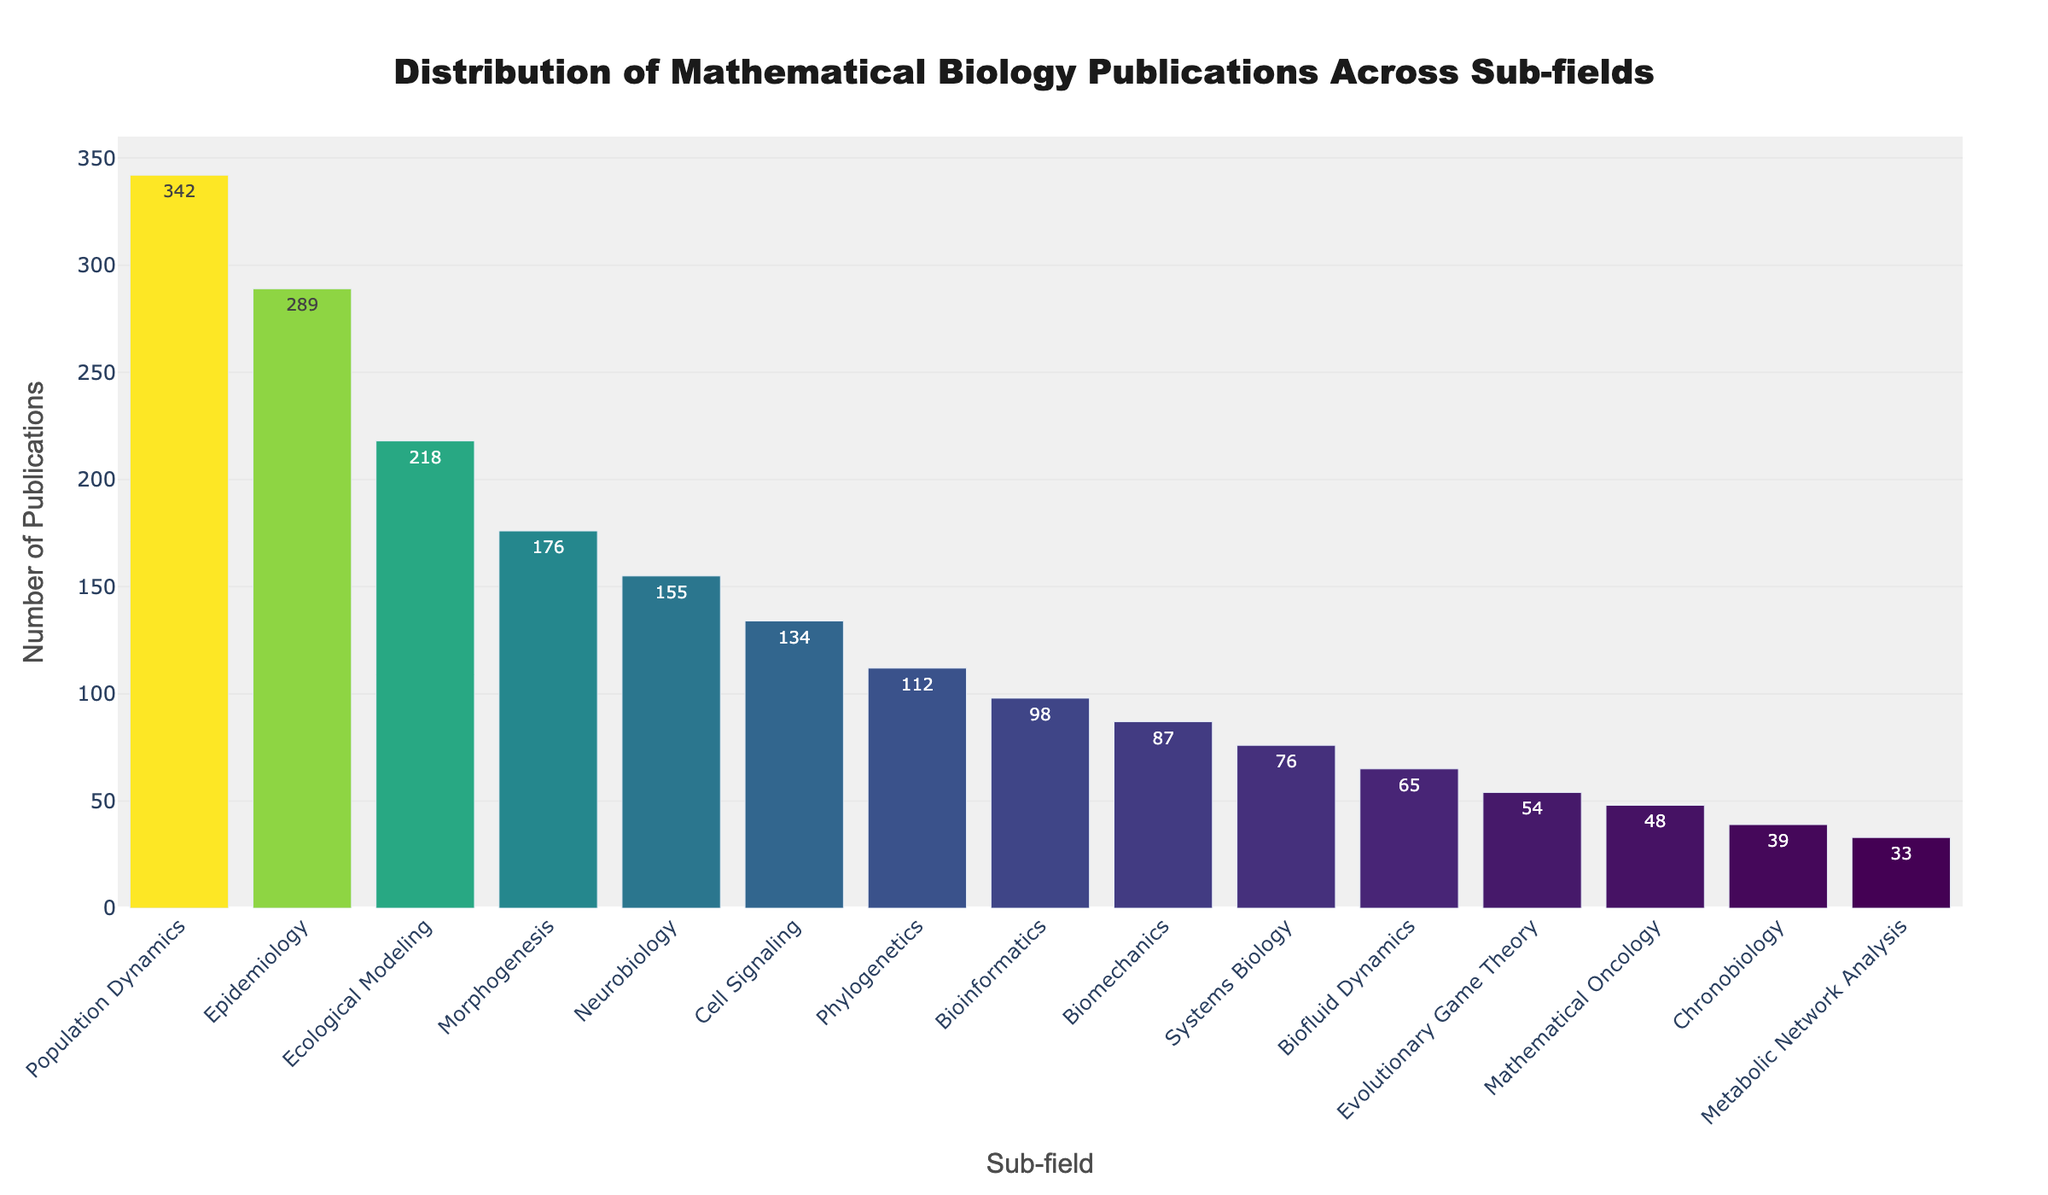What's the sub-field with the highest number of publications? The height of the bar represents the number of publications for each sub-field. The tallest bar corresponds to the sub-field with the highest number of publications. Population Dynamics has the tallest bar.
Answer: Population Dynamics What's the total number of publications in Neurobiology and Cell Signaling combined? To find the total, add the number of publications in Neurobiology (155) and Cell Signaling (134): 155 + 134 = 289.
Answer: 289 Which sub-field has fewer publications, Bioinformatics or Biomechanics? Compare the heights of the bars for Bioinformatics (98) and Biomechanics (87). Biomechanics has a shorter bar.
Answer: Biomechanics What's the difference in the number of publications between the sub-field with the most and the sub-field with the least publications? Subtract the number of publications in the sub-field with the least publications (Metabolic Network Analysis, 33) from the one with the most (Population Dynamics, 342): 342 - 33 = 309.
Answer: 309 How do the numbers of publications in Epidemiology and Evolutionary Game Theory compare? Compare the heights of the bars for Epidemiology (289) and Evolutionary Game Theory (54). Epidemiology has a higher number of publications.
Answer: Epidemiology What's the average number of publications among the top three sub-fields? The top three sub-fields by number of publications are Population Dynamics (342), Epidemiology (289), and Ecological Modeling (218). The average is calculated as (342 + 289 + 218) / 3 = 283.
Answer: 283 Are the colors of the bars for Bioinformatics and Systems Biology visually similar compared to the other bars? The color intensity reflects the number of publications. Bioinformatics (98) and Systems Biology (76) have close color intensities, which are lighter than most other bars with higher publication numbers.
Answer: Yes What's the range of publication numbers across all sub-fields? The range is found by subtracting the smallest number of publications (Metabolic Network Analysis, 33) from the largest (Population Dynamics, 342): 342 - 33 = 309.
Answer: 309 